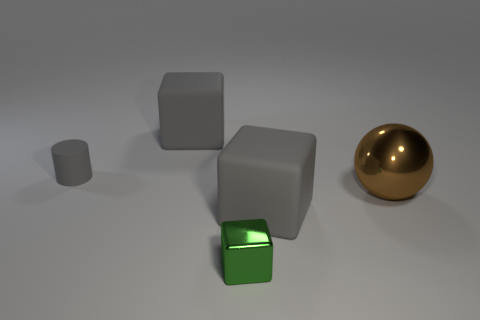Add 4 large yellow matte things. How many objects exist? 9 Subtract all cubes. How many objects are left? 2 Add 3 gray rubber cylinders. How many gray rubber cylinders exist? 4 Subtract 0 purple cubes. How many objects are left? 5 Subtract all shiny balls. Subtract all large brown balls. How many objects are left? 3 Add 3 tiny metal objects. How many tiny metal objects are left? 4 